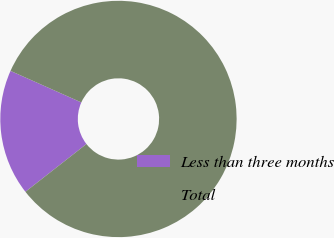Convert chart to OTSL. <chart><loc_0><loc_0><loc_500><loc_500><pie_chart><fcel>Less than three months<fcel>Total<nl><fcel>17.24%<fcel>82.76%<nl></chart> 